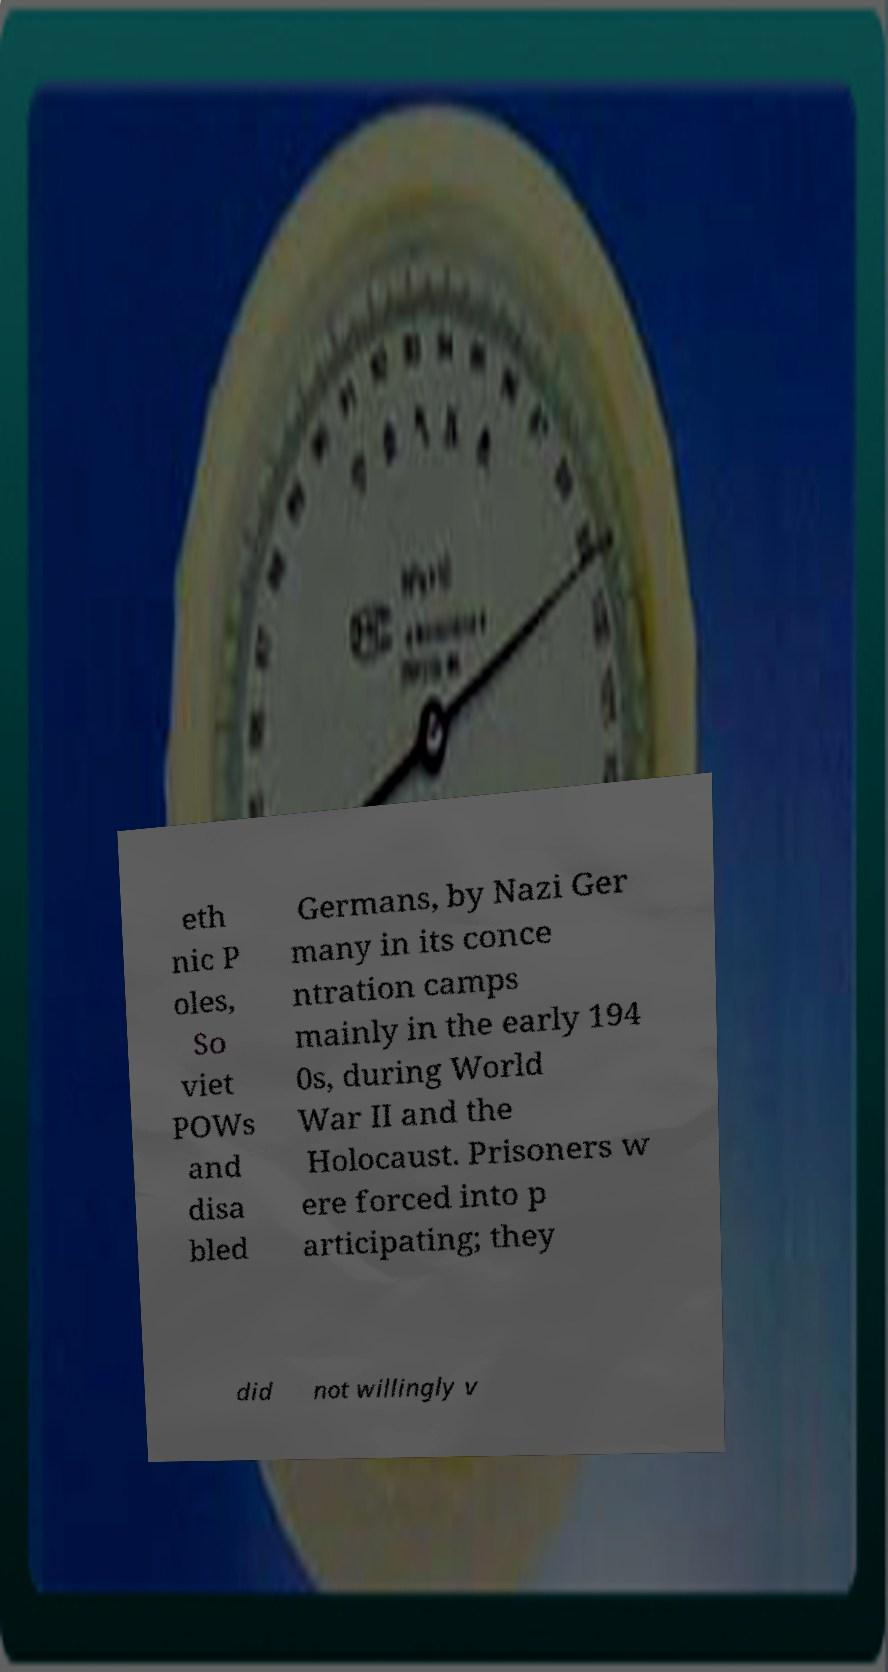What messages or text are displayed in this image? I need them in a readable, typed format. eth nic P oles, So viet POWs and disa bled Germans, by Nazi Ger many in its conce ntration camps mainly in the early 194 0s, during World War II and the Holocaust. Prisoners w ere forced into p articipating; they did not willingly v 